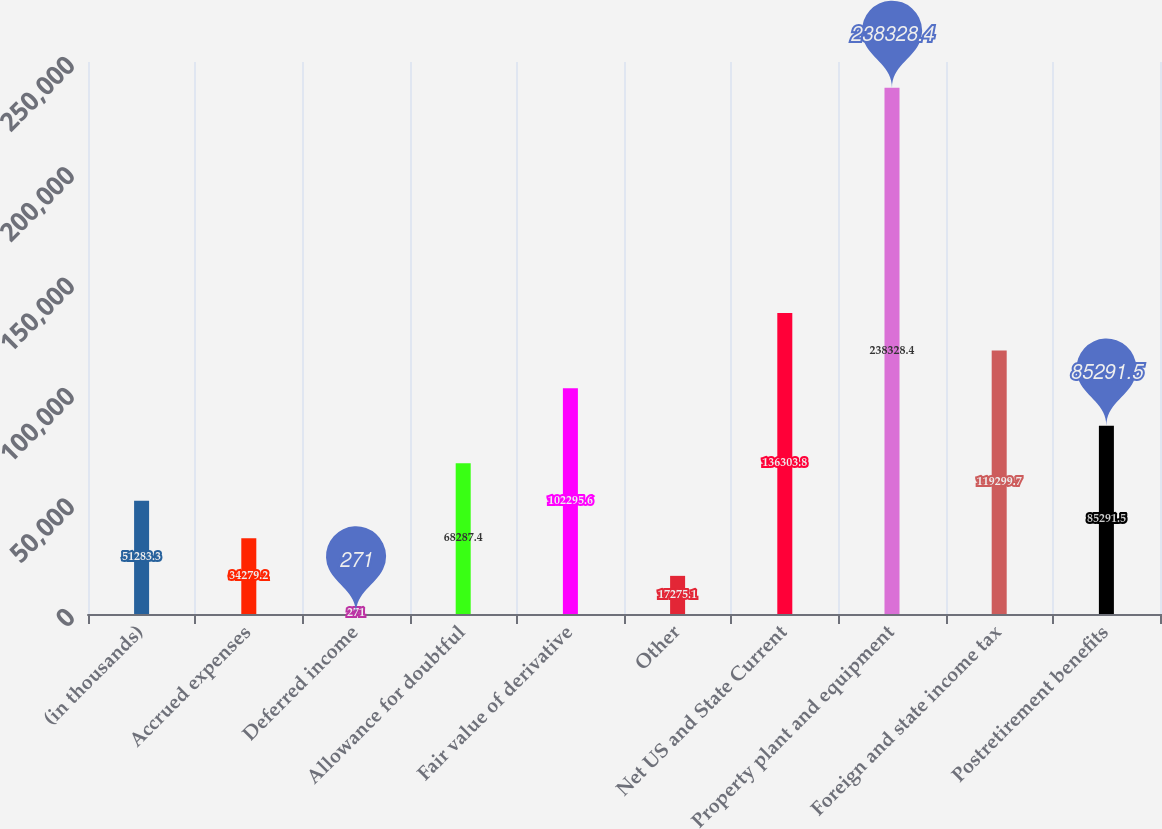<chart> <loc_0><loc_0><loc_500><loc_500><bar_chart><fcel>(in thousands)<fcel>Accrued expenses<fcel>Deferred income<fcel>Allowance for doubtful<fcel>Fair value of derivative<fcel>Other<fcel>Net US and State Current<fcel>Property plant and equipment<fcel>Foreign and state income tax<fcel>Postretirement benefits<nl><fcel>51283.3<fcel>34279.2<fcel>271<fcel>68287.4<fcel>102296<fcel>17275.1<fcel>136304<fcel>238328<fcel>119300<fcel>85291.5<nl></chart> 